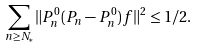Convert formula to latex. <formula><loc_0><loc_0><loc_500><loc_500>\sum _ { n \geq N _ { * } } \| P _ { n } ^ { 0 } ( P _ { n } - P _ { n } ^ { 0 } ) f \| ^ { 2 } \leq 1 / 2 .</formula> 